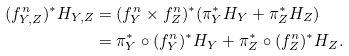Convert formula to latex. <formula><loc_0><loc_0><loc_500><loc_500>( f _ { Y , Z } ^ { n } ) ^ { * } H _ { Y , Z } & = ( f _ { Y } ^ { n } \times f _ { Z } ^ { n } ) ^ { * } ( \pi _ { Y } ^ { * } H _ { Y } + \pi _ { Z } ^ { * } H _ { Z } ) \\ & = \pi _ { Y } ^ { * } \circ ( f _ { Y } ^ { n } ) ^ { * } H _ { Y } + \pi _ { Z } ^ { * } \circ ( f _ { Z } ^ { n } ) ^ { * } H _ { Z } .</formula> 